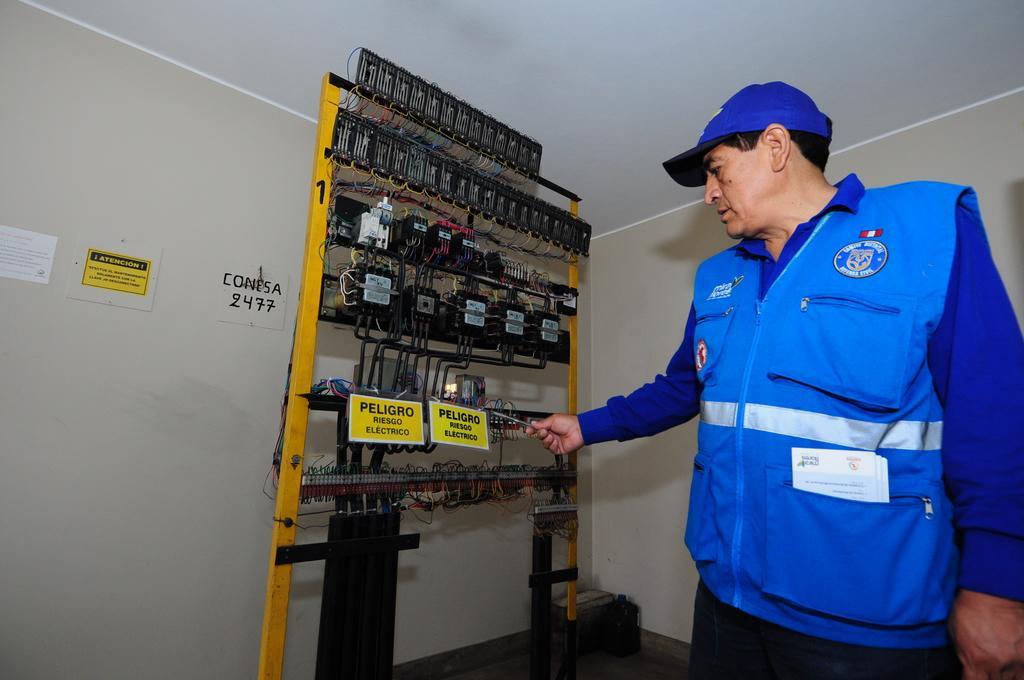How would you summarize this image in a sentence or two? In this picture there is a man who is standing on the right side of the image and there is an electric stand in the center of the image. 